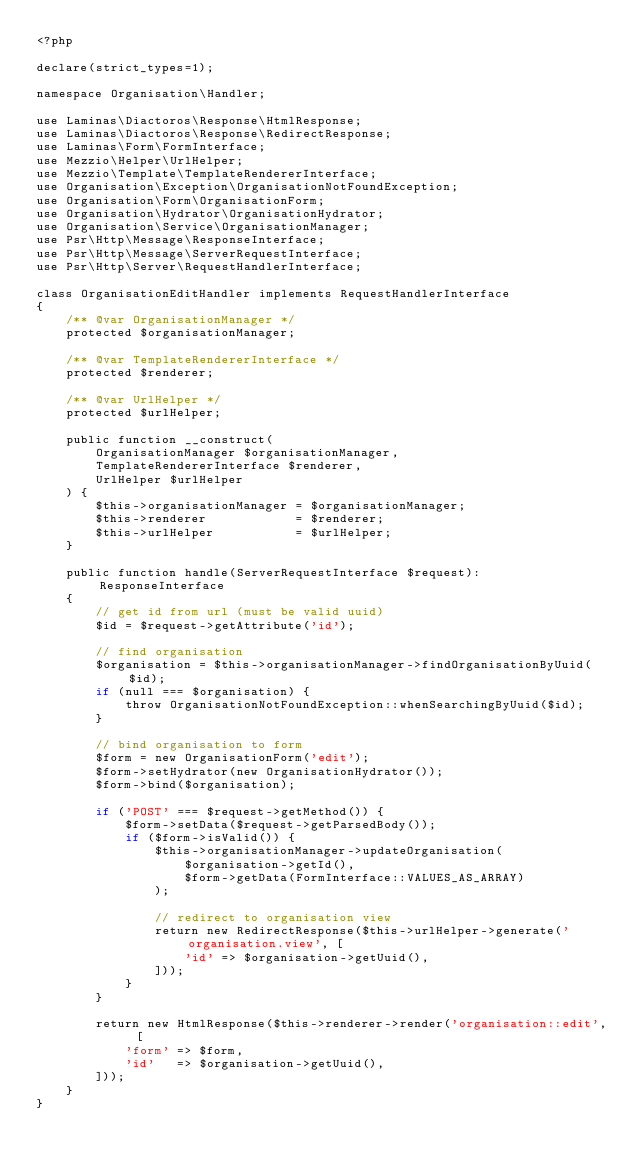<code> <loc_0><loc_0><loc_500><loc_500><_PHP_><?php

declare(strict_types=1);

namespace Organisation\Handler;

use Laminas\Diactoros\Response\HtmlResponse;
use Laminas\Diactoros\Response\RedirectResponse;
use Laminas\Form\FormInterface;
use Mezzio\Helper\UrlHelper;
use Mezzio\Template\TemplateRendererInterface;
use Organisation\Exception\OrganisationNotFoundException;
use Organisation\Form\OrganisationForm;
use Organisation\Hydrator\OrganisationHydrator;
use Organisation\Service\OrganisationManager;
use Psr\Http\Message\ResponseInterface;
use Psr\Http\Message\ServerRequestInterface;
use Psr\Http\Server\RequestHandlerInterface;

class OrganisationEditHandler implements RequestHandlerInterface
{
    /** @var OrganisationManager */
    protected $organisationManager;

    /** @var TemplateRendererInterface */
    protected $renderer;

    /** @var UrlHelper */
    protected $urlHelper;

    public function __construct(
        OrganisationManager $organisationManager,
        TemplateRendererInterface $renderer,
        UrlHelper $urlHelper
    ) {
        $this->organisationManager = $organisationManager;
        $this->renderer            = $renderer;
        $this->urlHelper           = $urlHelper;
    }

    public function handle(ServerRequestInterface $request): ResponseInterface
    {
        // get id from url (must be valid uuid)
        $id = $request->getAttribute('id');

        // find organisation
        $organisation = $this->organisationManager->findOrganisationByUuid($id);
        if (null === $organisation) {
            throw OrganisationNotFoundException::whenSearchingByUuid($id);
        }

        // bind organisation to form
        $form = new OrganisationForm('edit');
        $form->setHydrator(new OrganisationHydrator());
        $form->bind($organisation);

        if ('POST' === $request->getMethod()) {
            $form->setData($request->getParsedBody());
            if ($form->isValid()) {
                $this->organisationManager->updateOrganisation(
                    $organisation->getId(),
                    $form->getData(FormInterface::VALUES_AS_ARRAY)
                );

                // redirect to organisation view
                return new RedirectResponse($this->urlHelper->generate('organisation.view', [
                    'id' => $organisation->getUuid(),
                ]));
            }
        }

        return new HtmlResponse($this->renderer->render('organisation::edit', [
            'form' => $form,
            'id'   => $organisation->getUuid(),
        ]));
    }
}
</code> 